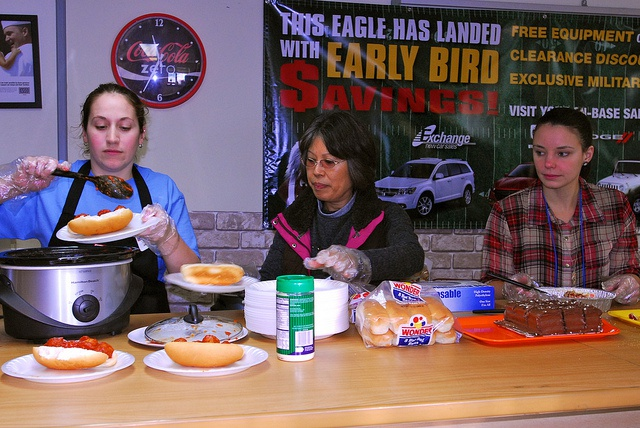Describe the objects in this image and their specific colors. I can see dining table in gray, tan, red, and lavender tones, people in gray, darkgray, black, lightblue, and brown tones, people in gray, black, maroon, and brown tones, people in gray, black, brown, and purple tones, and clock in gray, black, navy, purple, and maroon tones in this image. 